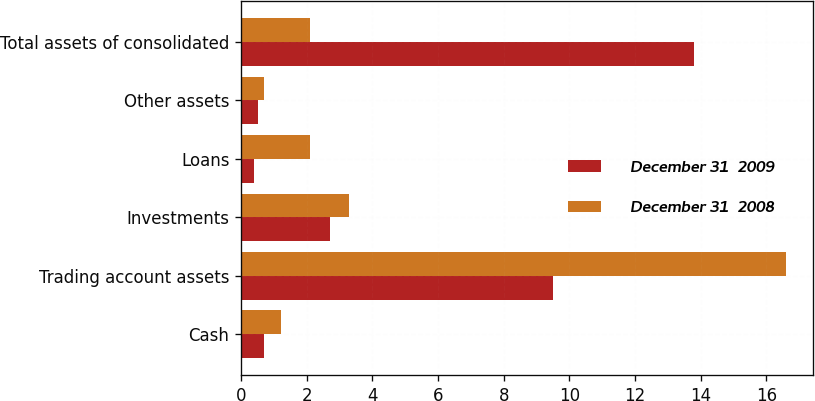<chart> <loc_0><loc_0><loc_500><loc_500><stacked_bar_chart><ecel><fcel>Cash<fcel>Trading account assets<fcel>Investments<fcel>Loans<fcel>Other assets<fcel>Total assets of consolidated<nl><fcel>December 31  2009<fcel>0.7<fcel>9.5<fcel>2.7<fcel>0.4<fcel>0.5<fcel>13.8<nl><fcel>December 31  2008<fcel>1.2<fcel>16.6<fcel>3.3<fcel>2.1<fcel>0.7<fcel>2.1<nl></chart> 